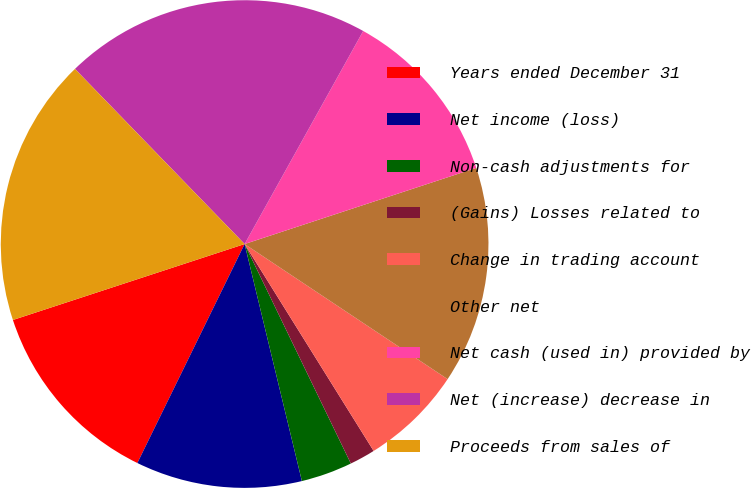Convert chart to OTSL. <chart><loc_0><loc_0><loc_500><loc_500><pie_chart><fcel>Years ended December 31<fcel>Net income (loss)<fcel>Non-cash adjustments for<fcel>(Gains) Losses related to<fcel>Change in trading account<fcel>Other net<fcel>Net cash (used in) provided by<fcel>Net (increase) decrease in<fcel>Proceeds from sales of<nl><fcel>12.71%<fcel>11.02%<fcel>3.4%<fcel>1.7%<fcel>6.78%<fcel>14.4%<fcel>11.86%<fcel>20.33%<fcel>17.79%<nl></chart> 